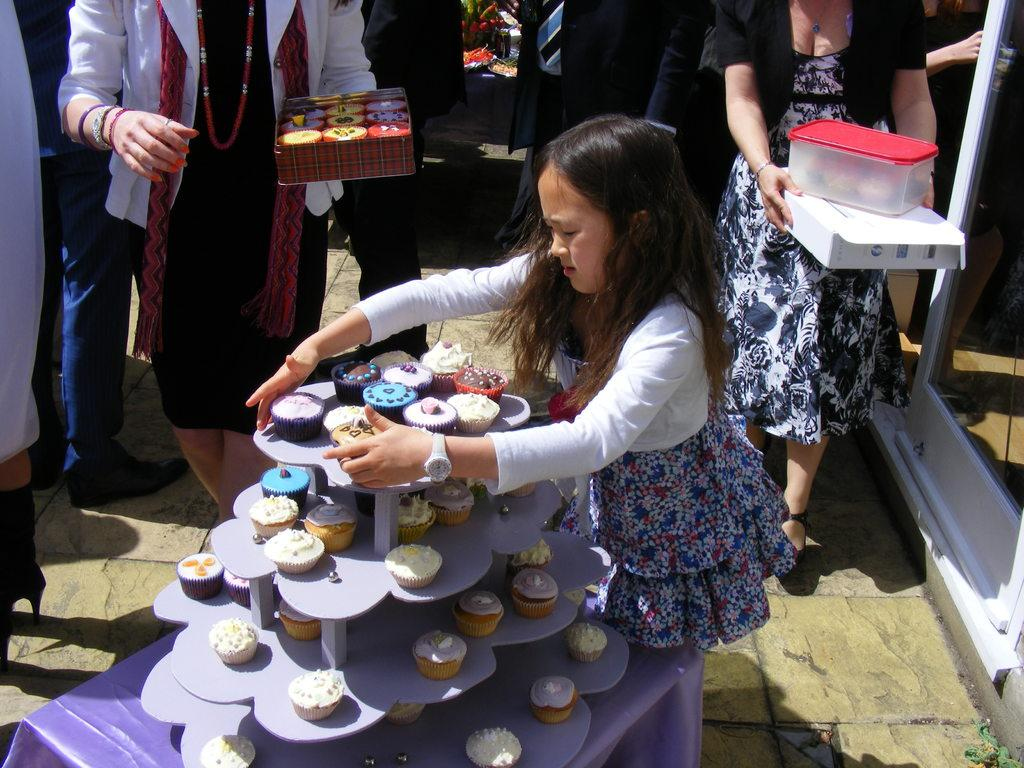Who is the main subject in the image? There is a girl in the image. What is the girl doing in the image? The girl is standing. What can be seen on the table in the image? There are cupcakes on a table in the image. What else is visible in the background of the image? There are people standing in the background of the image. What type of maid is attending the meeting in the image? There is no maid or meeting present in the image. What is the front of the image showing? The provided facts do not specify a "front" of the image, as it is a two-dimensional representation. 